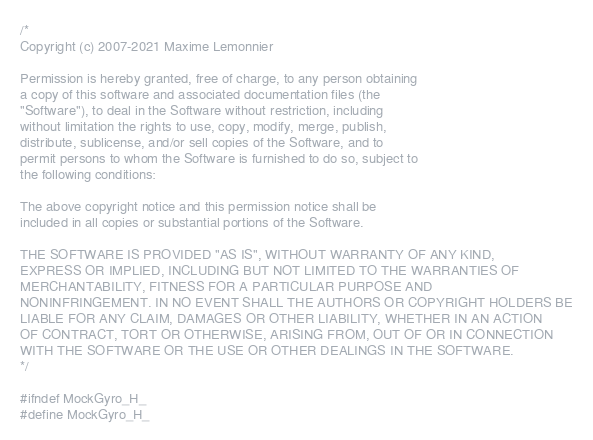Convert code to text. <code><loc_0><loc_0><loc_500><loc_500><_C_>/*
Copyright (c) 2007-2021 Maxime Lemonnier

Permission is hereby granted, free of charge, to any person obtaining
a copy of this software and associated documentation files (the
"Software"), to deal in the Software without restriction, including
without limitation the rights to use, copy, modify, merge, publish,
distribute, sublicense, and/or sell copies of the Software, and to
permit persons to whom the Software is furnished to do so, subject to
the following conditions:

The above copyright notice and this permission notice shall be
included in all copies or substantial portions of the Software.

THE SOFTWARE IS PROVIDED "AS IS", WITHOUT WARRANTY OF ANY KIND,
EXPRESS OR IMPLIED, INCLUDING BUT NOT LIMITED TO THE WARRANTIES OF
MERCHANTABILITY, FITNESS FOR A PARTICULAR PURPOSE AND
NONINFRINGEMENT. IN NO EVENT SHALL THE AUTHORS OR COPYRIGHT HOLDERS BE
LIABLE FOR ANY CLAIM, DAMAGES OR OTHER LIABILITY, WHETHER IN AN ACTION
OF CONTRACT, TORT OR OTHERWISE, ARISING FROM, OUT OF OR IN CONNECTION
WITH THE SOFTWARE OR THE USE OR OTHER DEALINGS IN THE SOFTWARE.
*/

#ifndef MockGyro_H_
#define MockGyro_H_
</code> 